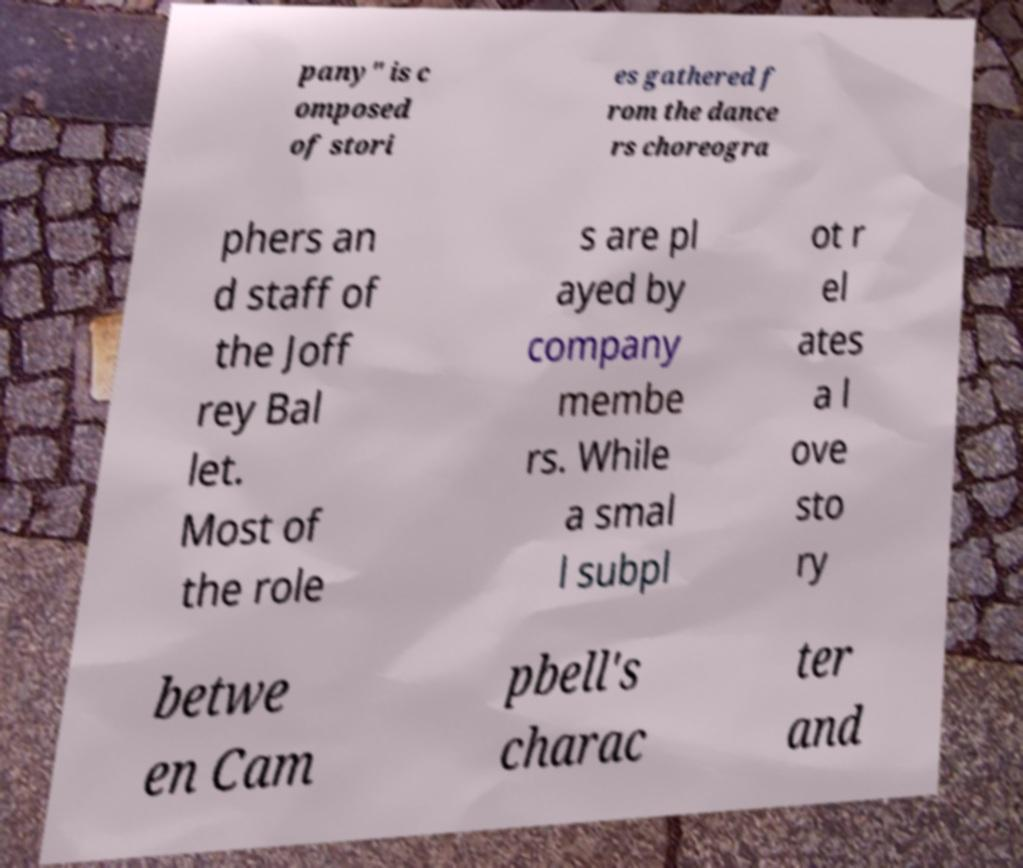Please read and relay the text visible in this image. What does it say? pany" is c omposed of stori es gathered f rom the dance rs choreogra phers an d staff of the Joff rey Bal let. Most of the role s are pl ayed by company membe rs. While a smal l subpl ot r el ates a l ove sto ry betwe en Cam pbell's charac ter and 